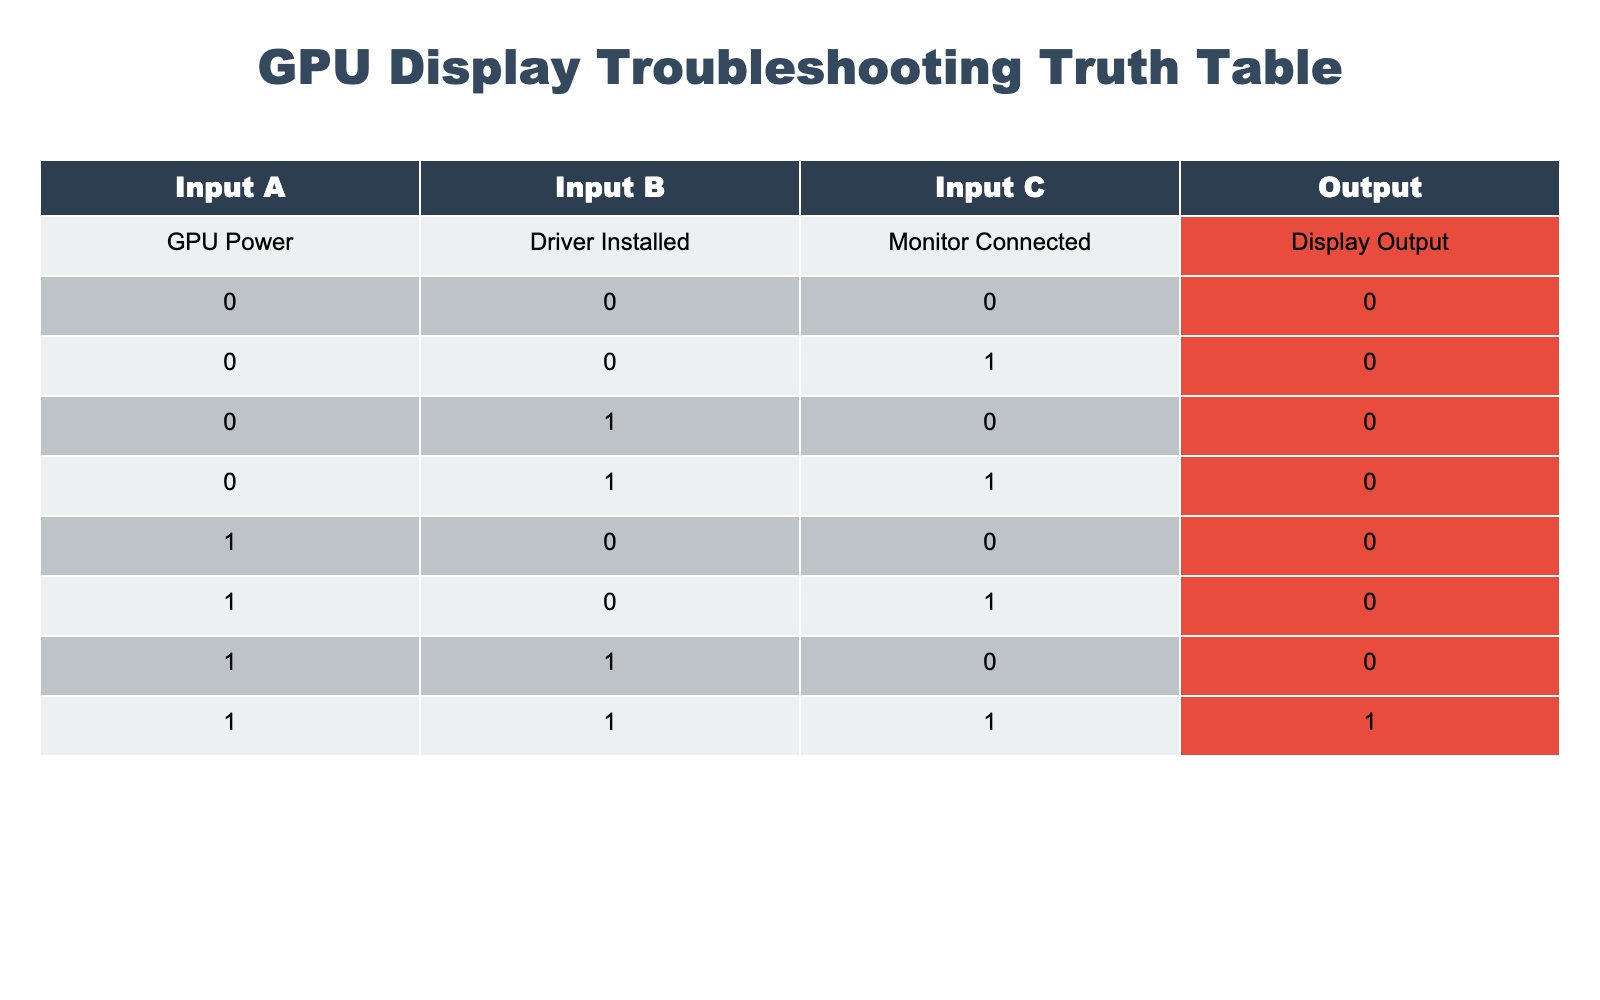What is the output when the GPU Power is 0 and the Driver is not installed with the Monitor connected? From the table, when GPU Power is 0, Driver Installed is 0, and Monitor Connected is 1, the Output value is 0.
Answer: 0 How many different combinations of GPU Power, Driver Installed, and Monitor Connected yield a Display Output of 1? By looking at the table, the only combination that yields a Display Output of 1 is when GPU Power is 1, Driver Installed is 1, and Monitor Connected is 1. Therefore, there is only 1 combination.
Answer: 1 Is the Display Output 0 when the GPU Power is 1 and the Monitor is not connected, regardless of the Driver status? The table shows that for GPU Power 1, Driver Installed 0, and Monitor Connected 0, the Output is 0. Additionally, output is also 0 for GPU Power 1, Driver Installed 1, and Monitor Connected 0. Therefore, the Display Output remains 0 under these circumstances.
Answer: Yes If the Monitor is connected, what are the possible combinations of GPU Power and Driver Installed that produce a Display Output of 1? Checking the table, the only combination where the Monitor is connected (1) that results in a Display Output of 1 is when GPU Power is 1 and Driver Installed is also 1. Thus, the possible combination is (1, 1).
Answer: (1, 1) What is the total number of scenarios listed in the table where the Output is 0? Examining the table, we can see there are 7 rows (0, 0, 0), (0, 0, 1), (0, 1, 0), (0, 1, 1), (1, 0, 0), (1, 0, 1), and (1, 1, 0) that have an Output of 0.
Answer: 7 Is there any scenario in the table where the Driver is installed (1) and the Display Output is also 0? From the table, when Driver Installed is 1, the Output is 0 for two cases: (0, 1, 0) and (1, 0, 1). It confirms there are indeed scenarios where the Driver is installed but the Display Output is still 0.
Answer: Yes How many scenarios show the Monitor is not connected (0) while Output is 0? In the table, the following scenarios have the Monitor not connected (0) and Output is 0: (0, 0, 0), (0, 1, 0), (1, 0, 0), and (1, 0, 1). This shows there are 4 scenarios with this condition.
Answer: 4 What percentage of the total scenarios results in Display Output of 1? There are 8 total scenarios listed in the table. Only 1 of those scenarios produces a Display Output of 1. Therefore, the percentage is (1/8) * 100 = 12.5%.
Answer: 12.5% 